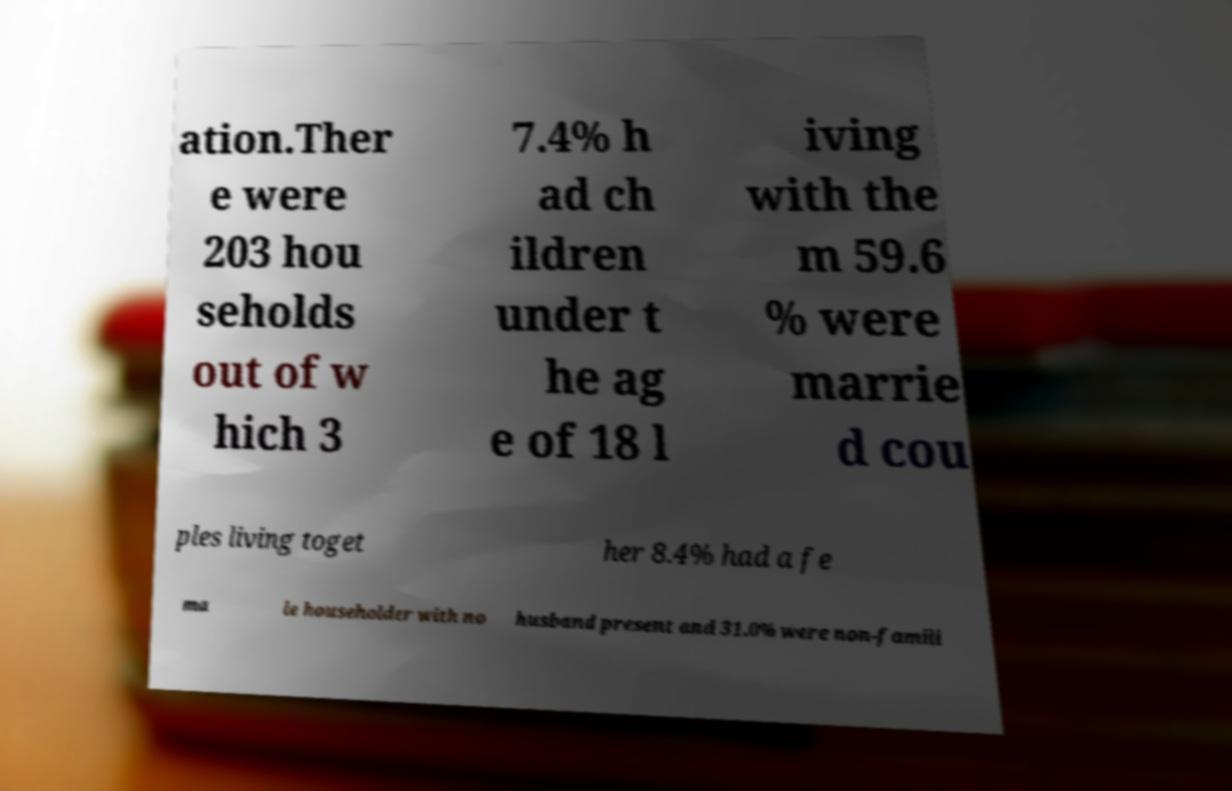Could you extract and type out the text from this image? ation.Ther e were 203 hou seholds out of w hich 3 7.4% h ad ch ildren under t he ag e of 18 l iving with the m 59.6 % were marrie d cou ples living toget her 8.4% had a fe ma le householder with no husband present and 31.0% were non-famili 